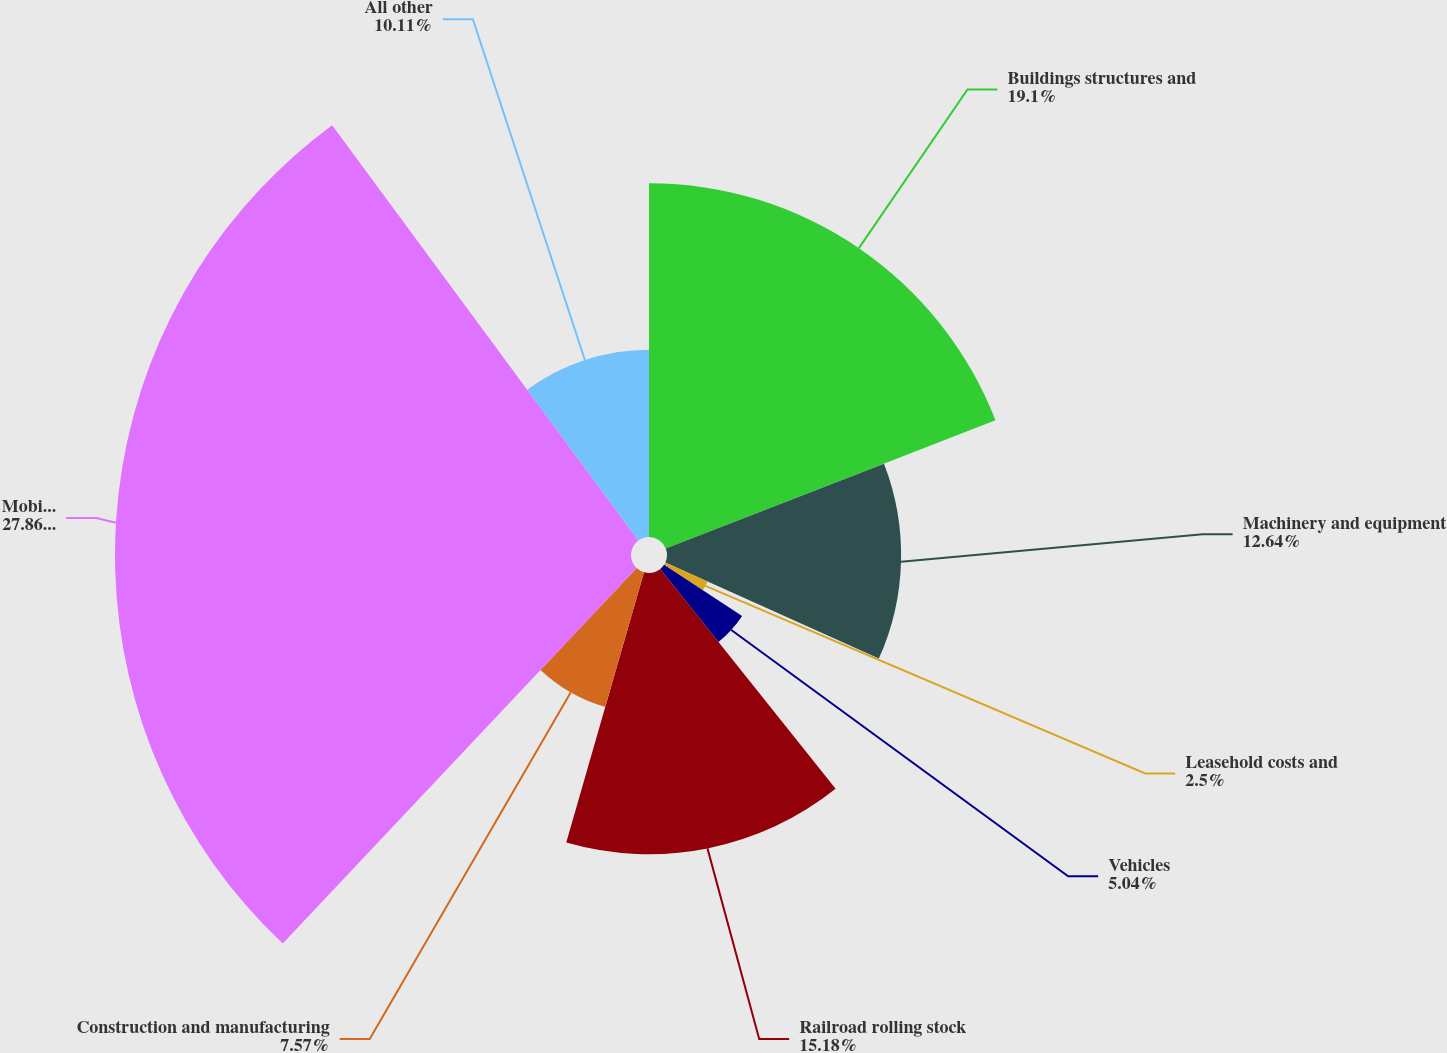Convert chart. <chart><loc_0><loc_0><loc_500><loc_500><pie_chart><fcel>Buildings structures and<fcel>Machinery and equipment<fcel>Leasehold costs and<fcel>Vehicles<fcel>Railroad rolling stock<fcel>Construction and manufacturing<fcel>Mobile equipment<fcel>All other<nl><fcel>19.1%<fcel>12.64%<fcel>2.5%<fcel>5.04%<fcel>15.18%<fcel>7.57%<fcel>27.86%<fcel>10.11%<nl></chart> 